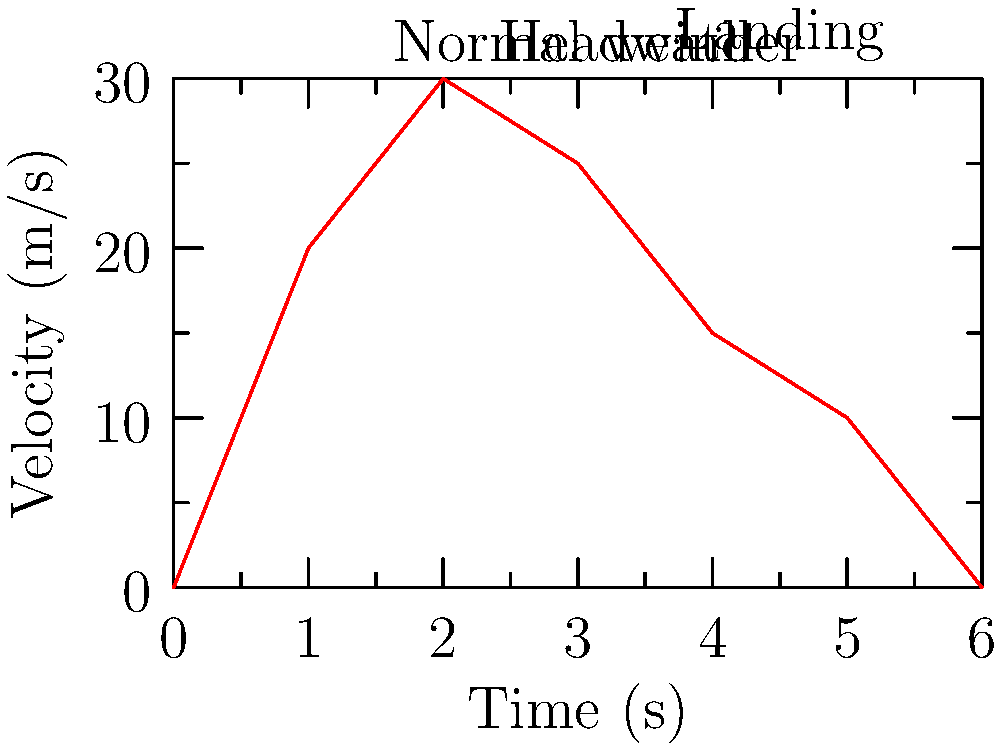A delivery drone accelerates from rest to 30 m/s in normal weather conditions, then encounters a headwind that causes it to decelerate before finally landing. Given the velocity-time graph above, calculate the drone's average acceleration during the first 2 seconds of its flight. To calculate the average acceleration during the first 2 seconds, we need to use the formula:

$$ a = \frac{\Delta v}{\Delta t} $$

Where:
- $a$ is the average acceleration
- $\Delta v$ is the change in velocity
- $\Delta t$ is the change in time

From the graph, we can see:
1. Initial velocity at t = 0 s: $v_i = 0$ m/s
2. Final velocity at t = 2 s: $v_f = 30$ m/s
3. Time interval: $\Delta t = 2$ s

Calculating the change in velocity:
$$ \Delta v = v_f - v_i = 30 - 0 = 30 \text{ m/s} $$

Now, we can substitute these values into the acceleration formula:

$$ a = \frac{\Delta v}{\Delta t} = \frac{30 \text{ m/s}}{2 \text{ s}} = 15 \text{ m/s}^2 $$

Therefore, the average acceleration during the first 2 seconds is 15 m/s².
Answer: 15 m/s² 